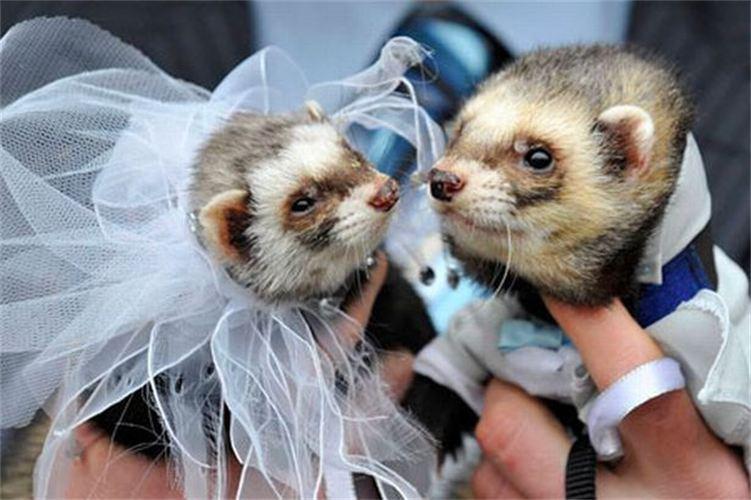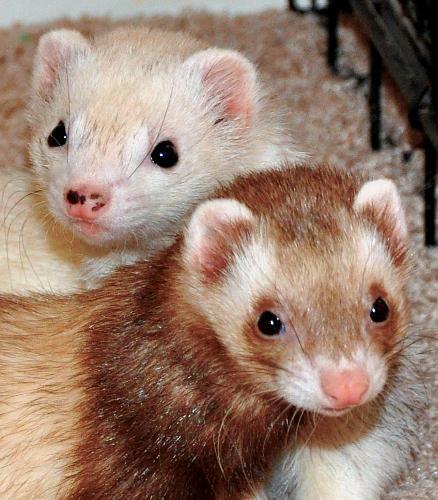The first image is the image on the left, the second image is the image on the right. Considering the images on both sides, is "Each image contains two ferrets, and one image shows hands holding up unclothed ferrets." valid? Answer yes or no. No. The first image is the image on the left, the second image is the image on the right. For the images displayed, is the sentence "Two ferrets with the same fur color pattern are wearing clothes." factually correct? Answer yes or no. Yes. 